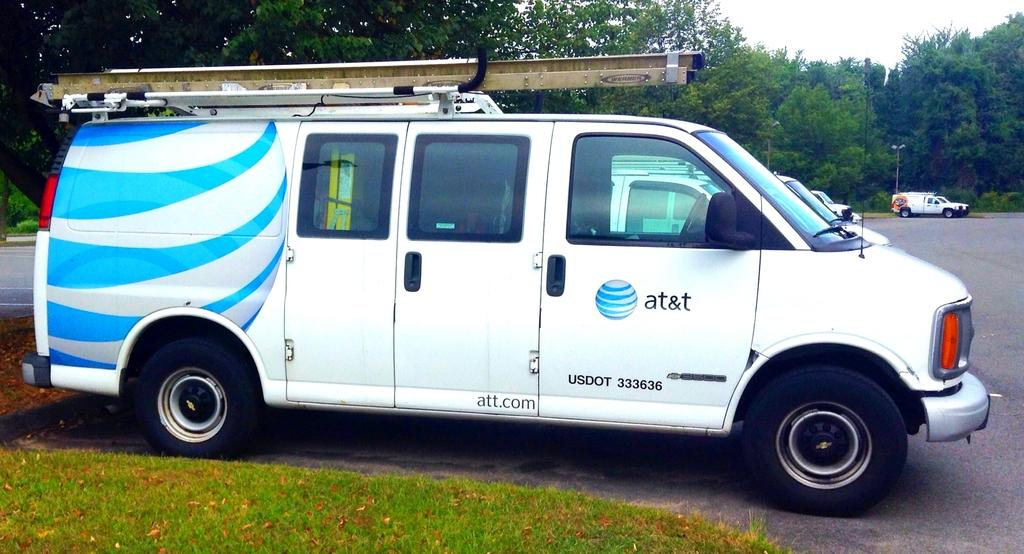<image>
Give a short and clear explanation of the subsequent image. White van parked outside with the word ATT on the side. 